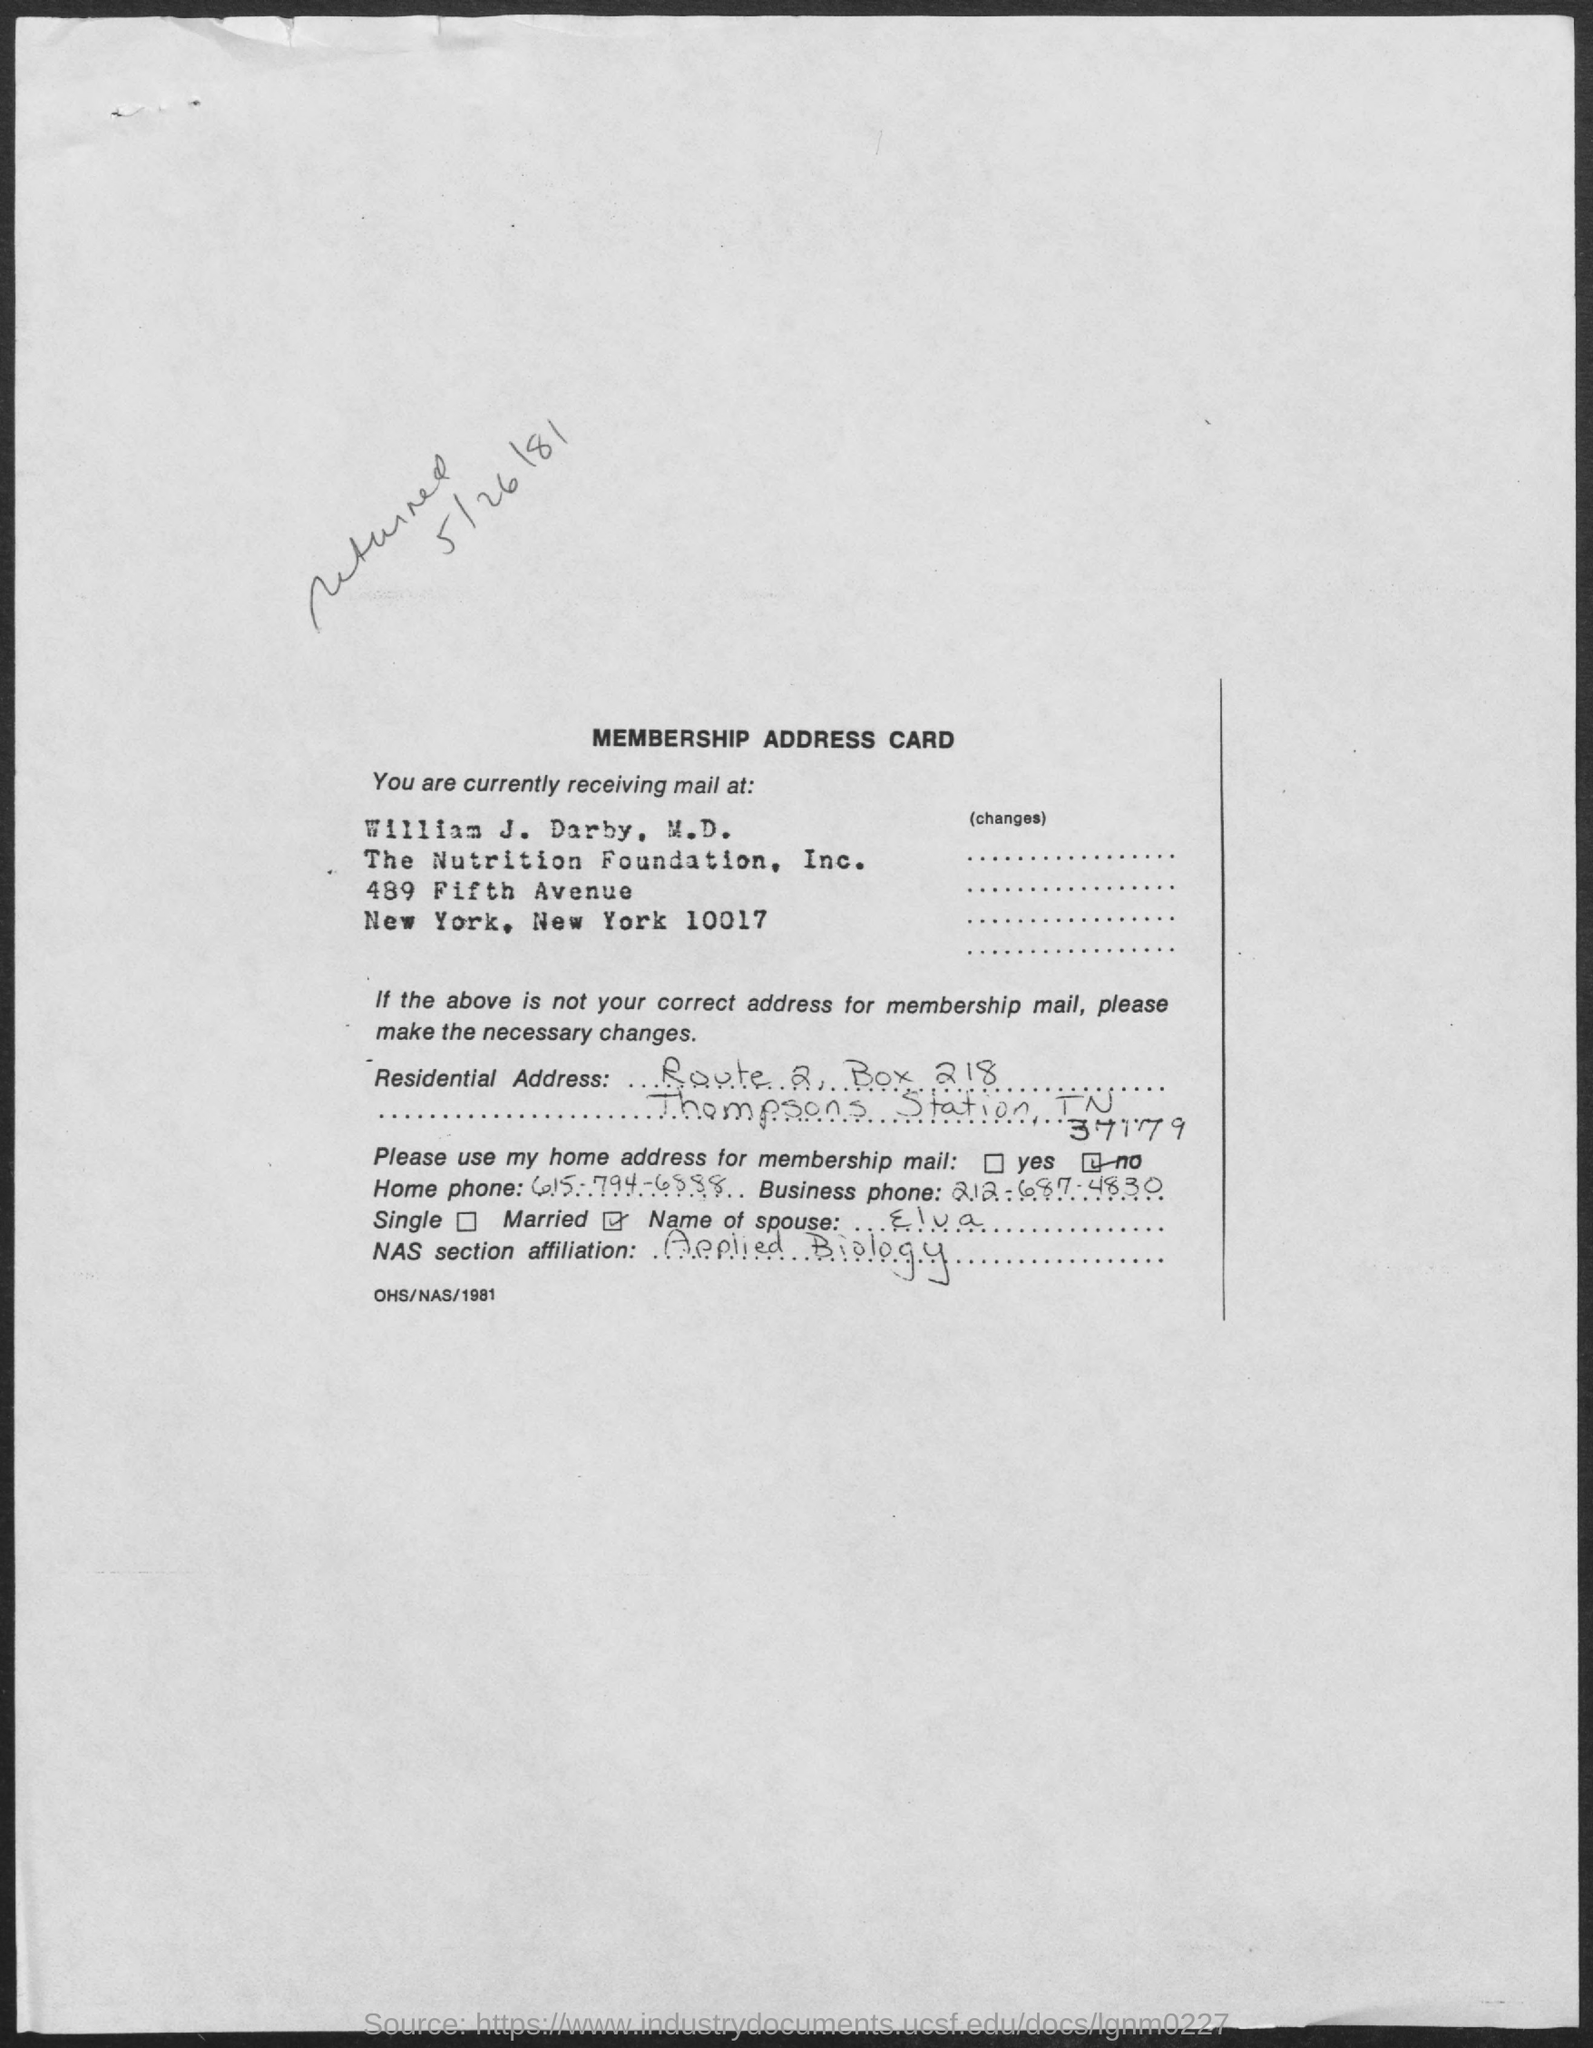Mention a couple of crucial points in this snapshot. The name of the foundation mentioned is The Nutrition Foundation, Inc. The business phone number is 212-687-4830. The box number mentioned is 218. The NAS section affiliation mentioned in the given document is "applied biology. The home phone number mentioned is 615-794-6888. 